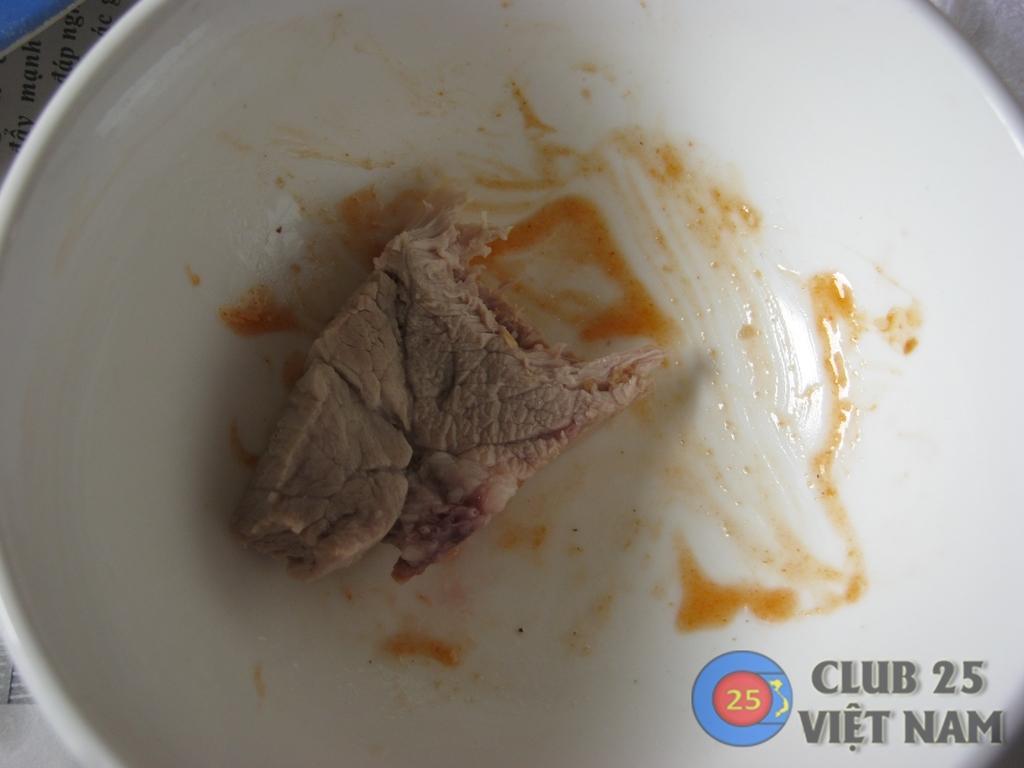Could you give a brief overview of what you see in this image? In this image there is a plate on which there is a piece of meat. Beside the meat there is a sauce. 